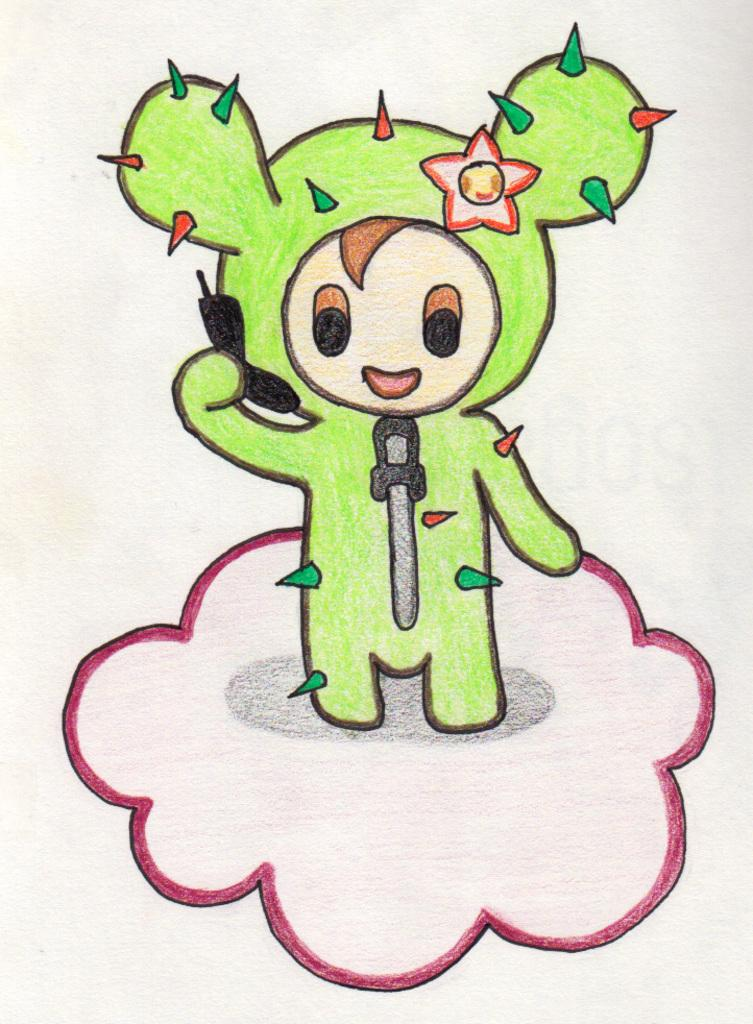What is depicted in the image? There is a drawing of a toy in the image. What is the medium used for the drawing? The drawing is on a paper. What type of toad can be seen in the image? There is no toad present in the image; it features a drawing of a toy. What is the view like from the tray in the image? There is no tray present in the image, so it is not possible to describe the view from it. 